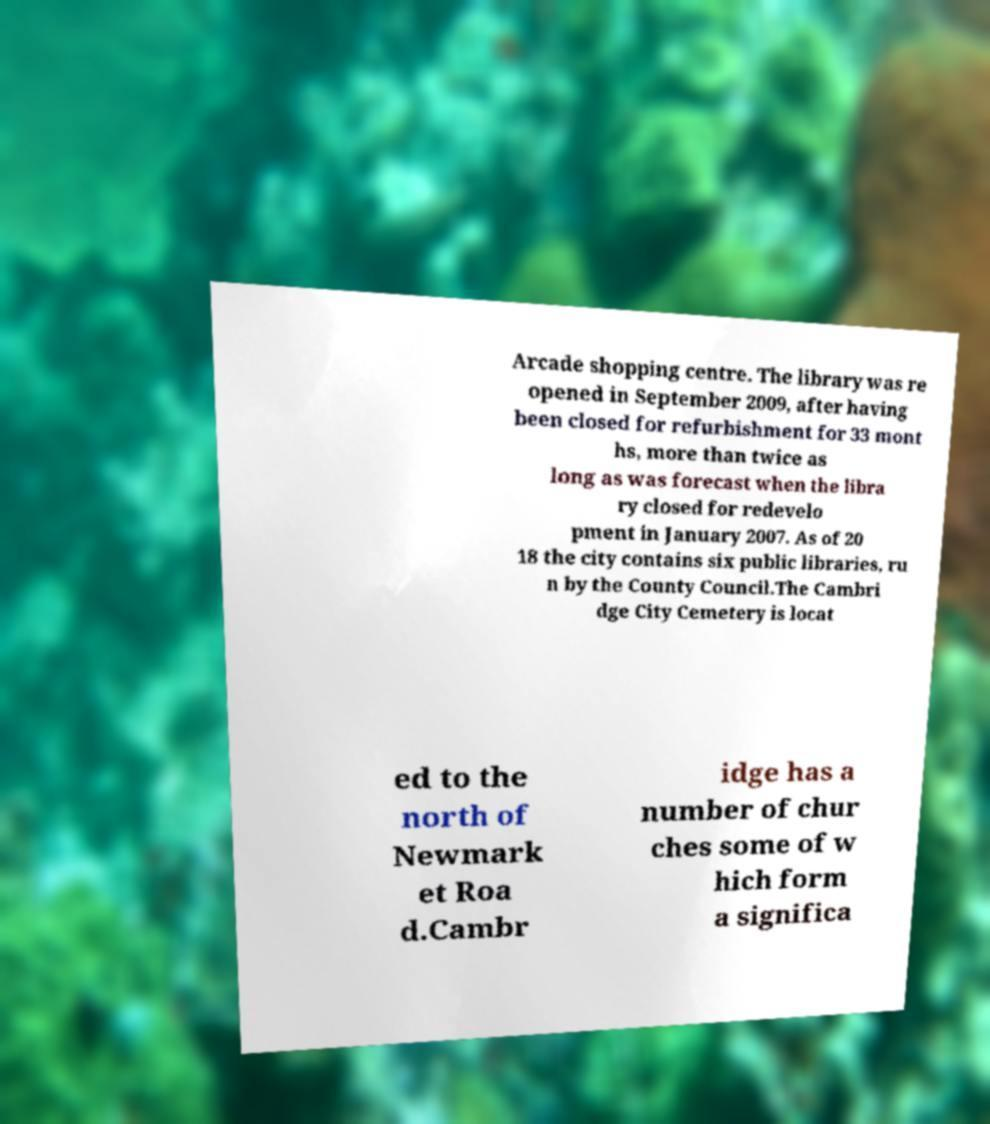Please identify and transcribe the text found in this image. Arcade shopping centre. The library was re opened in September 2009, after having been closed for refurbishment for 33 mont hs, more than twice as long as was forecast when the libra ry closed for redevelo pment in January 2007. As of 20 18 the city contains six public libraries, ru n by the County Council.The Cambri dge City Cemetery is locat ed to the north of Newmark et Roa d.Cambr idge has a number of chur ches some of w hich form a significa 